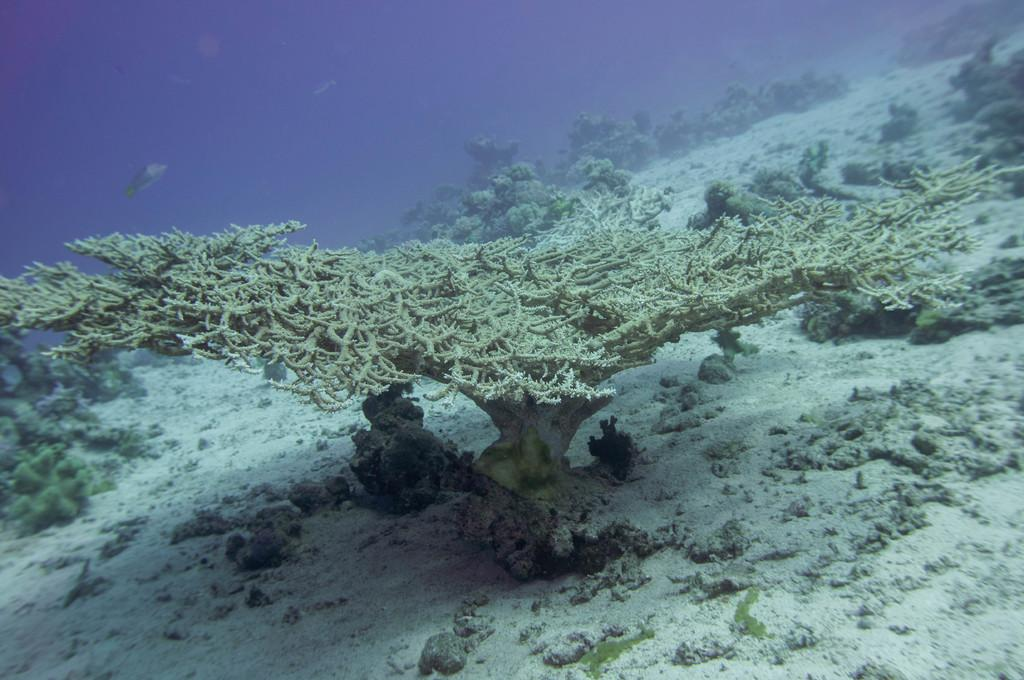What type of environment is shown in the image? The image depicts deep water. Are there any plants visible in the water? Yes, there are water plants in the image. What can be seen on the bottom of the water? There is a white sand surface with stones in the image. What type of animals can be seen in the image? There are fish visible in the image. What color crayon is being used to draw the fish in the image? There are no crayons or drawings present in the image; it is a photograph of a natural underwater environment. Can you hear any music playing in the image? The image is a still photograph and does not contain any audible elements, such as music. 